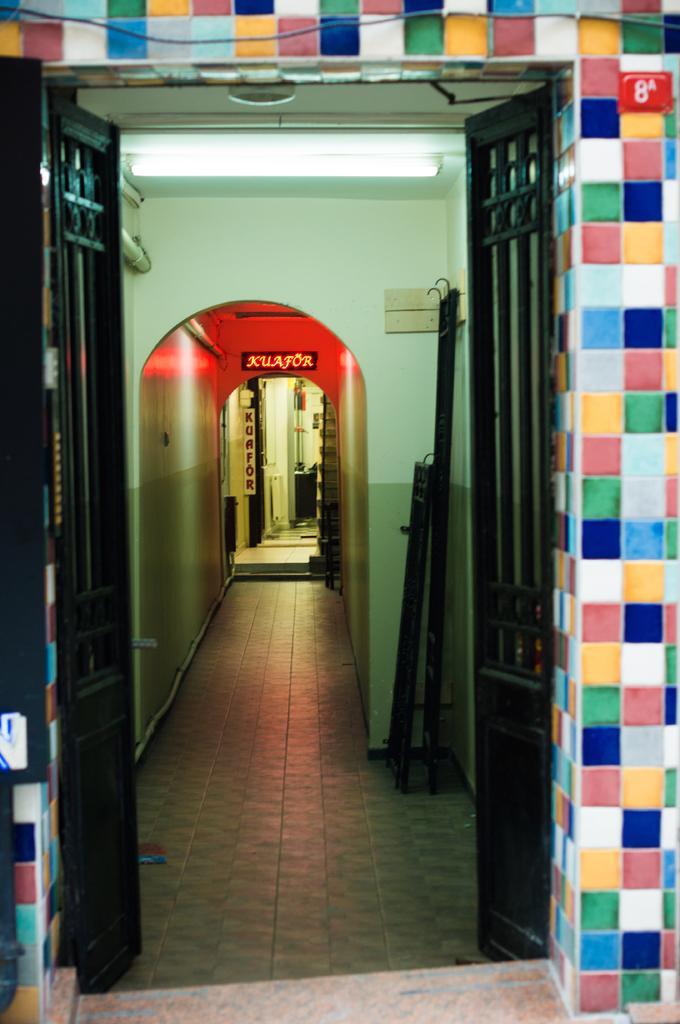How would you summarize this image in a sentence or two? In the foreground of the picture we can see gate. In the middle of the picture we can see light and walls. In the background we can see name plates, door and wall. 